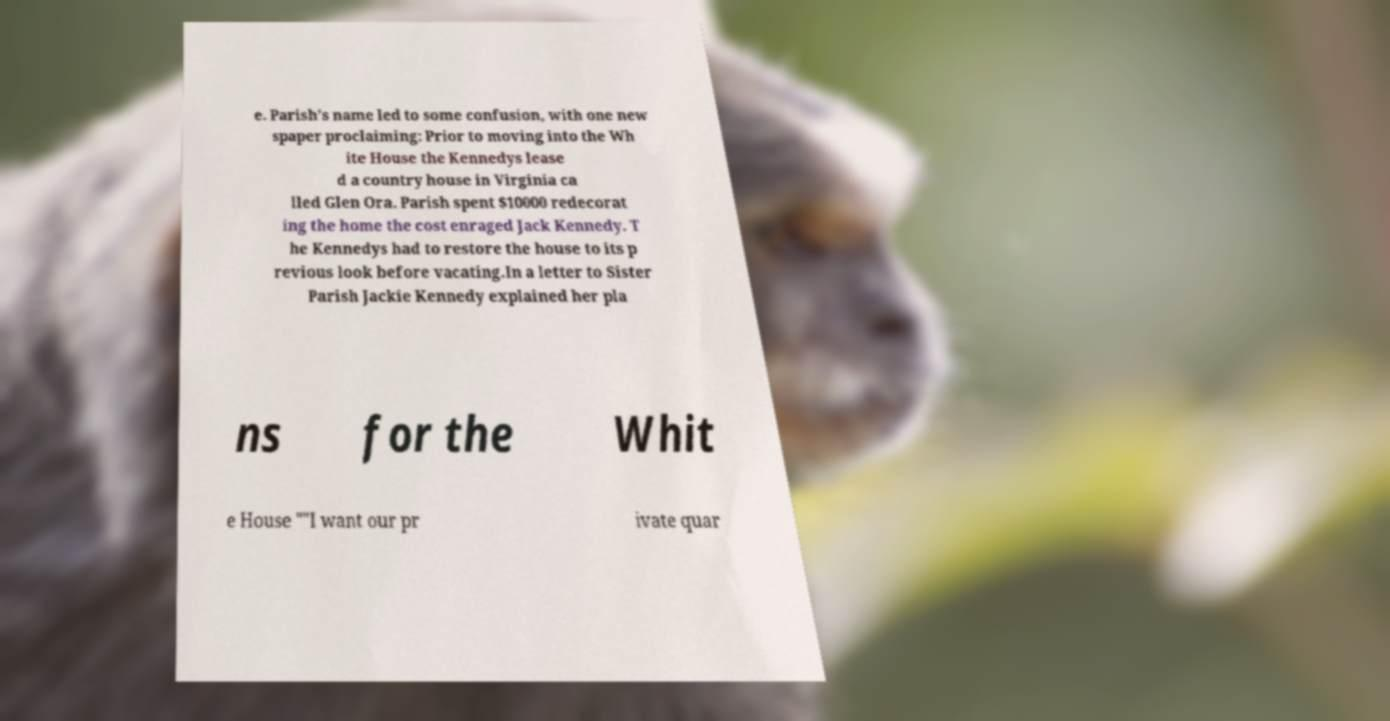Please read and relay the text visible in this image. What does it say? e. Parish's name led to some confusion, with one new spaper proclaiming: Prior to moving into the Wh ite House the Kennedys lease d a country house in Virginia ca lled Glen Ora. Parish spent $10000 redecorat ing the home the cost enraged Jack Kennedy. T he Kennedys had to restore the house to its p revious look before vacating.In a letter to Sister Parish Jackie Kennedy explained her pla ns for the Whit e House ""I want our pr ivate quar 